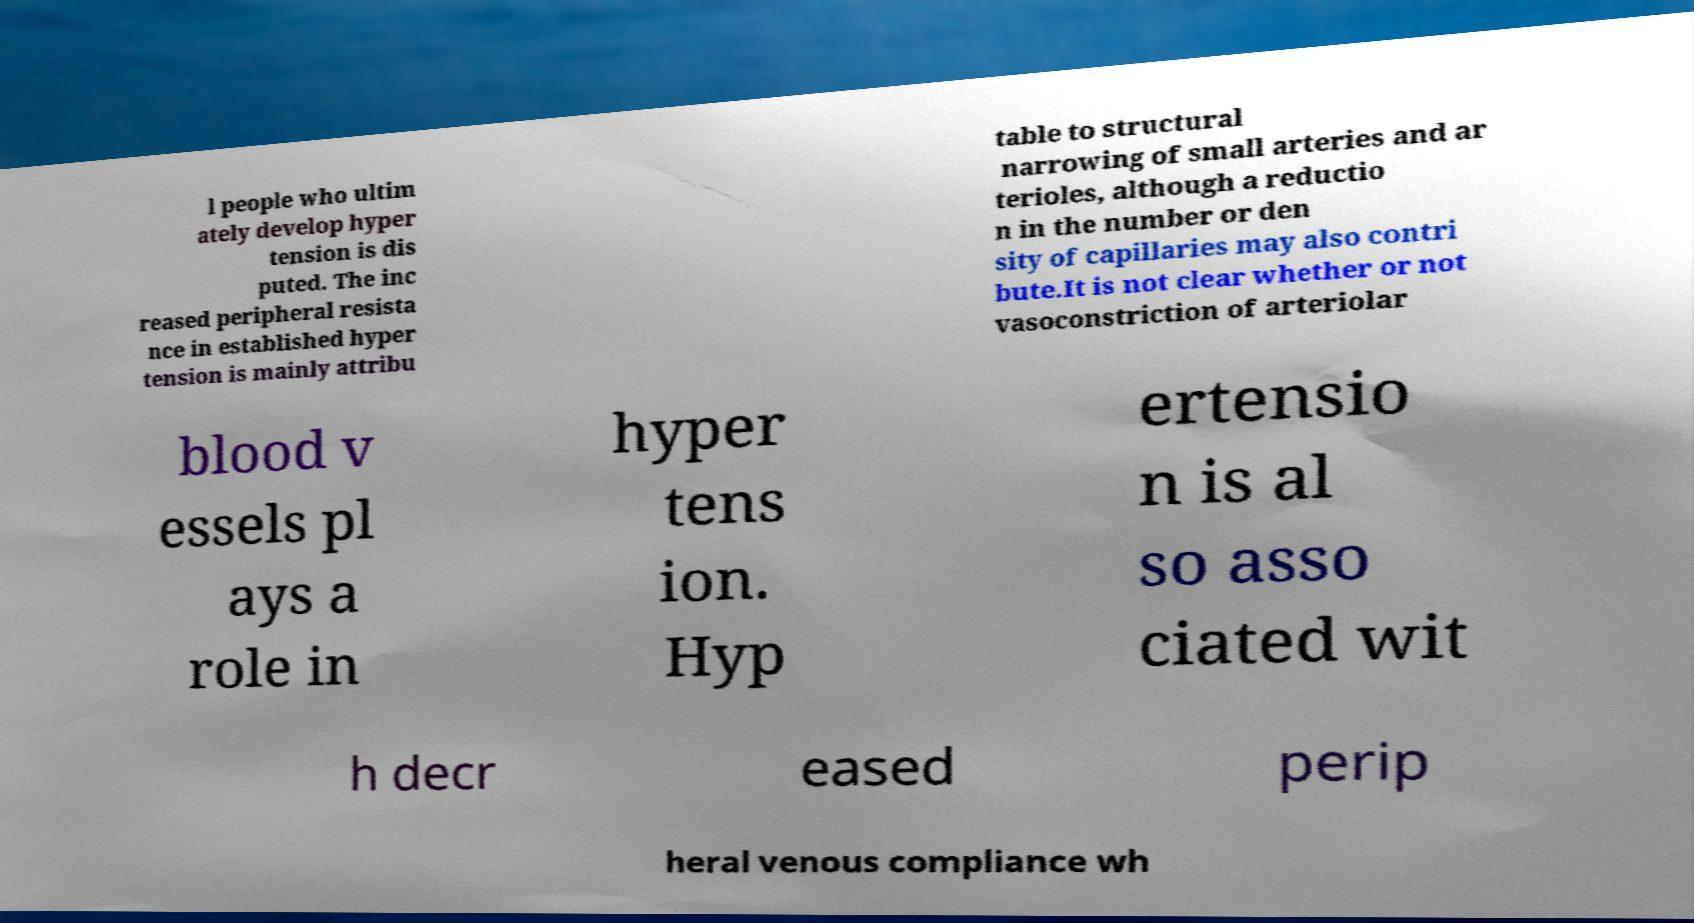I need the written content from this picture converted into text. Can you do that? l people who ultim ately develop hyper tension is dis puted. The inc reased peripheral resista nce in established hyper tension is mainly attribu table to structural narrowing of small arteries and ar terioles, although a reductio n in the number or den sity of capillaries may also contri bute.It is not clear whether or not vasoconstriction of arteriolar blood v essels pl ays a role in hyper tens ion. Hyp ertensio n is al so asso ciated wit h decr eased perip heral venous compliance wh 